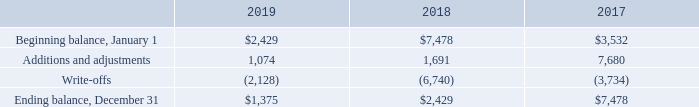Allowance for Doubtful Accounts
The Company bases its allowance for doubtful accounts on its historical collection experience and a review in each period of the status of the then outstanding accounts receivable.
A reconciliation of the beginning and ending amount of allowance for doubtful accounts is as follows (in thousands):
The Company recognized bad debt expense of $0.5 million, $0.8 million, and $1.4 million for the years ended December 31, 2019, 2018, and 2017, respectively.
What was the company's bad debt expense for the year ending December 31, 2018? $0.8 million. What was the beginning balance in January 1 2019?
Answer scale should be: thousand. $2,429. What was the ending balance in December 31 2017?
Answer scale should be: thousand. $7,478. What is the change in additions and adjustments between 2017 and 2018?
Answer scale should be: thousand. (1,691-7,680)
Answer: -5989. What is the average year-on-year change for Additions and adjustments from 2017-2019? 
Answer scale should be: percent. ((1,074-1,691)/1,691+(1,691-7,680)/7,680)/2
Answer: -57.23. What is the percentage change in the ending balance between 2018 and 2019?
Answer scale should be: percent. ($1,375-$2,429)/$2,429
Answer: -43.39. 